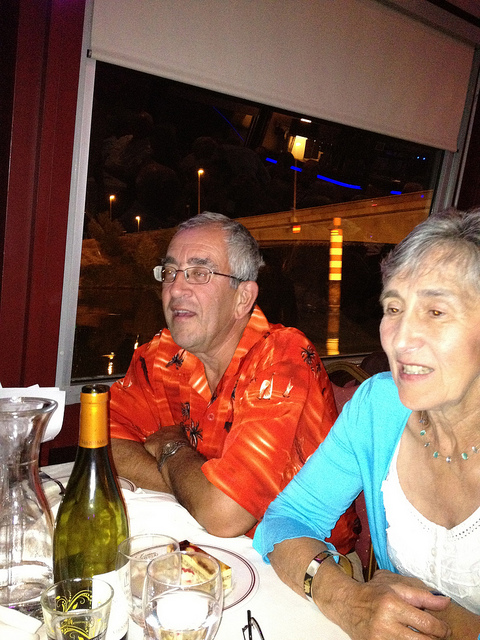Please provide the bounding box coordinate of the region this sentence describes: woman. The bounding box coordinates for the region describing the woman are approximately [0.51, 0.32, 0.87, 0.99]. 